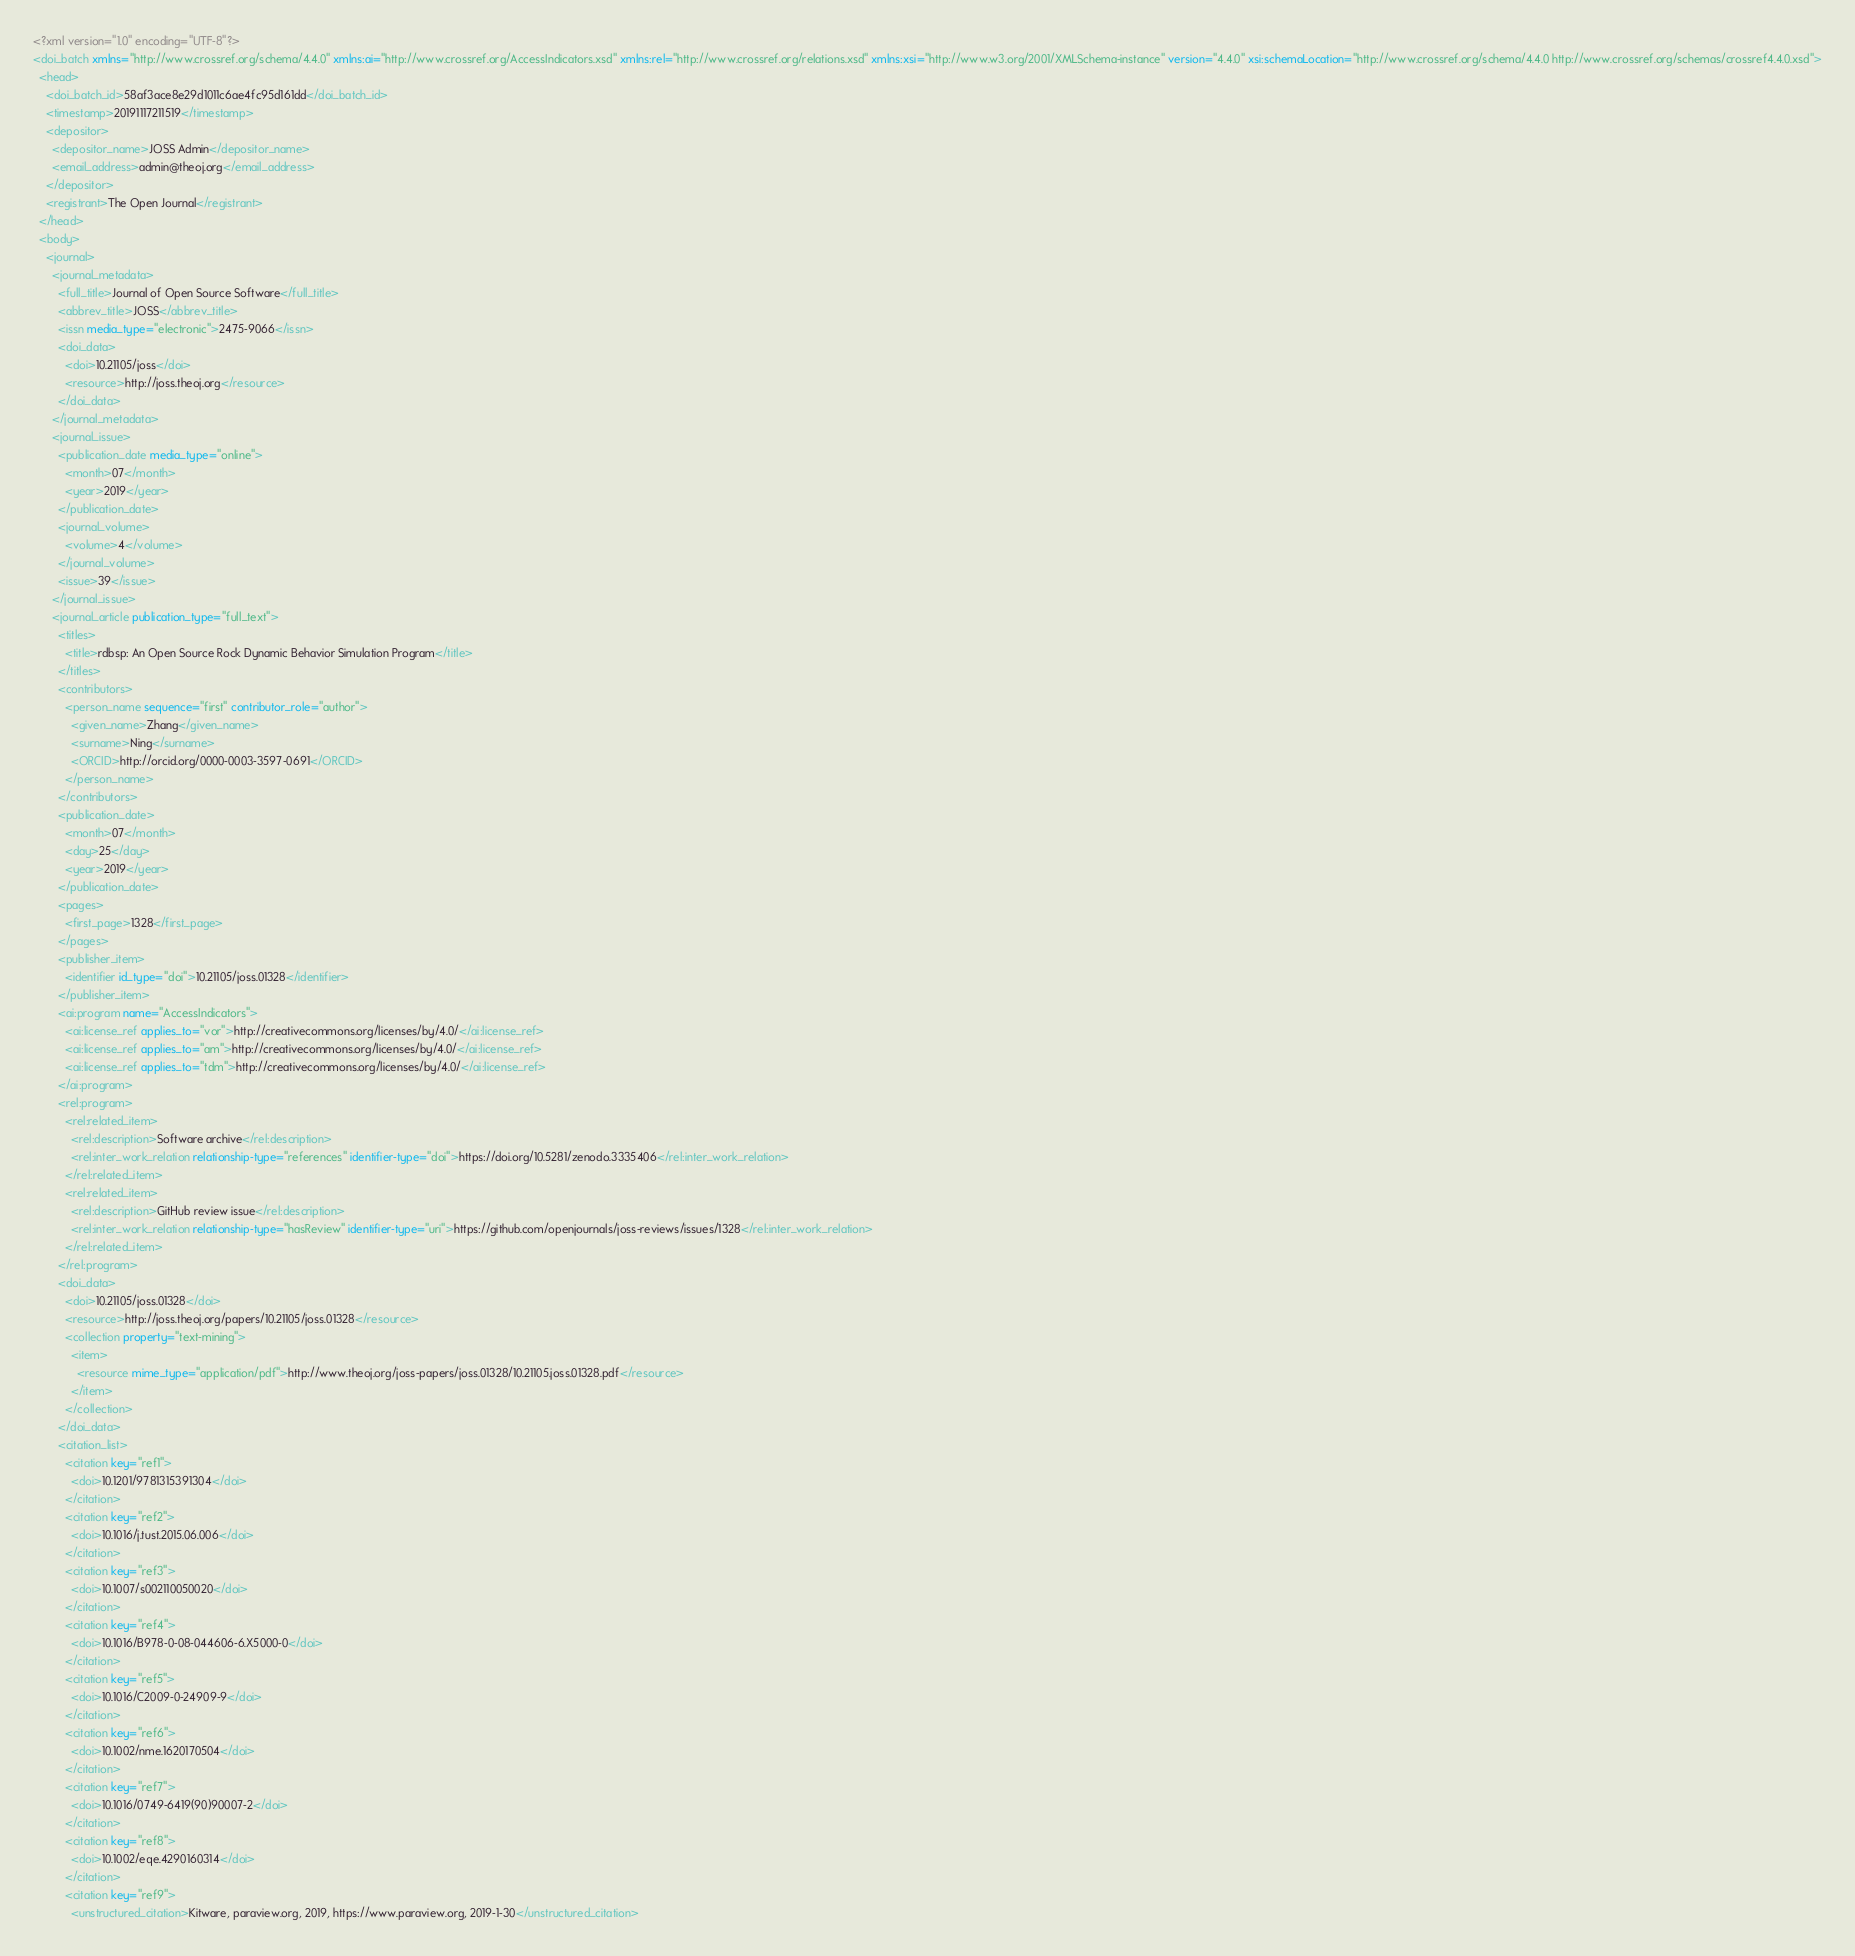Convert code to text. <code><loc_0><loc_0><loc_500><loc_500><_XML_><?xml version="1.0" encoding="UTF-8"?>
<doi_batch xmlns="http://www.crossref.org/schema/4.4.0" xmlns:ai="http://www.crossref.org/AccessIndicators.xsd" xmlns:rel="http://www.crossref.org/relations.xsd" xmlns:xsi="http://www.w3.org/2001/XMLSchema-instance" version="4.4.0" xsi:schemaLocation="http://www.crossref.org/schema/4.4.0 http://www.crossref.org/schemas/crossref4.4.0.xsd">
  <head>
    <doi_batch_id>58af3ace8e29d1011c6ae4fc95d161dd</doi_batch_id>
    <timestamp>20191117211519</timestamp>
    <depositor>
      <depositor_name>JOSS Admin</depositor_name>
      <email_address>admin@theoj.org</email_address>
    </depositor>
    <registrant>The Open Journal</registrant>
  </head>
  <body>
    <journal>
      <journal_metadata>
        <full_title>Journal of Open Source Software</full_title>
        <abbrev_title>JOSS</abbrev_title>
        <issn media_type="electronic">2475-9066</issn>
        <doi_data>
          <doi>10.21105/joss</doi>
          <resource>http://joss.theoj.org</resource>
        </doi_data>
      </journal_metadata>
      <journal_issue>
        <publication_date media_type="online">
          <month>07</month>
          <year>2019</year>
        </publication_date>
        <journal_volume>
          <volume>4</volume>
        </journal_volume>
        <issue>39</issue>
      </journal_issue>
      <journal_article publication_type="full_text">
        <titles>
          <title>rdbsp: An Open Source Rock Dynamic Behavior Simulation Program</title>
        </titles>
        <contributors>
          <person_name sequence="first" contributor_role="author">
            <given_name>Zhang</given_name>
            <surname>Ning</surname>
            <ORCID>http://orcid.org/0000-0003-3597-0691</ORCID>
          </person_name>
        </contributors>
        <publication_date>
          <month>07</month>
          <day>25</day>
          <year>2019</year>
        </publication_date>
        <pages>
          <first_page>1328</first_page>
        </pages>
        <publisher_item>
          <identifier id_type="doi">10.21105/joss.01328</identifier>
        </publisher_item>
        <ai:program name="AccessIndicators">
          <ai:license_ref applies_to="vor">http://creativecommons.org/licenses/by/4.0/</ai:license_ref>
          <ai:license_ref applies_to="am">http://creativecommons.org/licenses/by/4.0/</ai:license_ref>
          <ai:license_ref applies_to="tdm">http://creativecommons.org/licenses/by/4.0/</ai:license_ref>
        </ai:program>
        <rel:program>
          <rel:related_item>
            <rel:description>Software archive</rel:description>
            <rel:inter_work_relation relationship-type="references" identifier-type="doi">https://doi.org/10.5281/zenodo.3335406</rel:inter_work_relation>
          </rel:related_item>
          <rel:related_item>
            <rel:description>GitHub review issue</rel:description>
            <rel:inter_work_relation relationship-type="hasReview" identifier-type="uri">https://github.com/openjournals/joss-reviews/issues/1328</rel:inter_work_relation>
          </rel:related_item>
        </rel:program>
        <doi_data>
          <doi>10.21105/joss.01328</doi>
          <resource>http://joss.theoj.org/papers/10.21105/joss.01328</resource>
          <collection property="text-mining">
            <item>
              <resource mime_type="application/pdf">http://www.theoj.org/joss-papers/joss.01328/10.21105.joss.01328.pdf</resource>
            </item>
          </collection>
        </doi_data>
        <citation_list>
          <citation key="ref1">
            <doi>10.1201/9781315391304</doi>
          </citation>
          <citation key="ref2">
            <doi>10.1016/j.tust.2015.06.006</doi>
          </citation>
          <citation key="ref3">
            <doi>10.1007/s002110050020</doi>
          </citation>
          <citation key="ref4">
            <doi>10.1016/B978-0-08-044606-6.X5000-0</doi>
          </citation>
          <citation key="ref5">
            <doi>10.1016/C2009-0-24909-9</doi>
          </citation>
          <citation key="ref6">
            <doi>10.1002/nme.1620170504</doi>
          </citation>
          <citation key="ref7">
            <doi>10.1016/0749-6419(90)90007-2</doi>
          </citation>
          <citation key="ref8">
            <doi>10.1002/eqe.4290160314</doi>
          </citation>
          <citation key="ref9">
            <unstructured_citation>Kitware, paraview.org, 2019, https://www.paraview.org, 2019-1-30</unstructured_citation></code> 